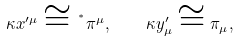Convert formula to latex. <formula><loc_0><loc_0><loc_500><loc_500>\kappa x ^ { \prime \mu } \cong \, ^ { ^ { * } } \pi ^ { \mu } , \quad \kappa y ^ { \prime } _ { \mu } \cong \pi _ { \mu } ,</formula> 